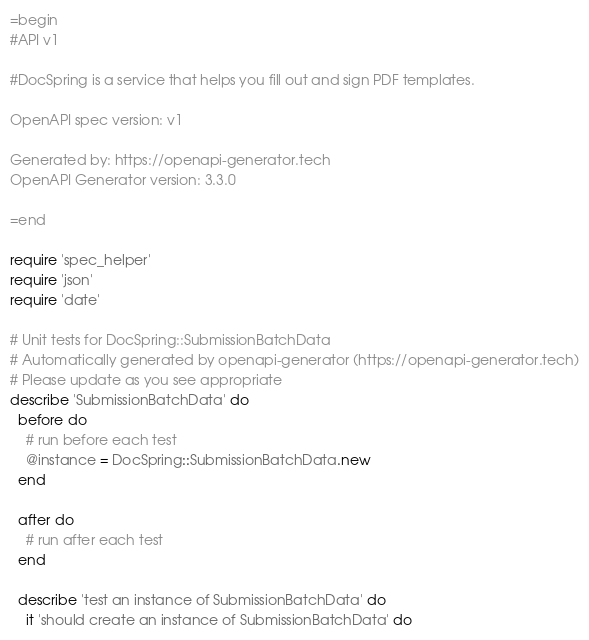Convert code to text. <code><loc_0><loc_0><loc_500><loc_500><_Ruby_>=begin
#API v1

#DocSpring is a service that helps you fill out and sign PDF templates.

OpenAPI spec version: v1

Generated by: https://openapi-generator.tech
OpenAPI Generator version: 3.3.0

=end

require 'spec_helper'
require 'json'
require 'date'

# Unit tests for DocSpring::SubmissionBatchData
# Automatically generated by openapi-generator (https://openapi-generator.tech)
# Please update as you see appropriate
describe 'SubmissionBatchData' do
  before do
    # run before each test
    @instance = DocSpring::SubmissionBatchData.new
  end

  after do
    # run after each test
  end

  describe 'test an instance of SubmissionBatchData' do
    it 'should create an instance of SubmissionBatchData' do</code> 